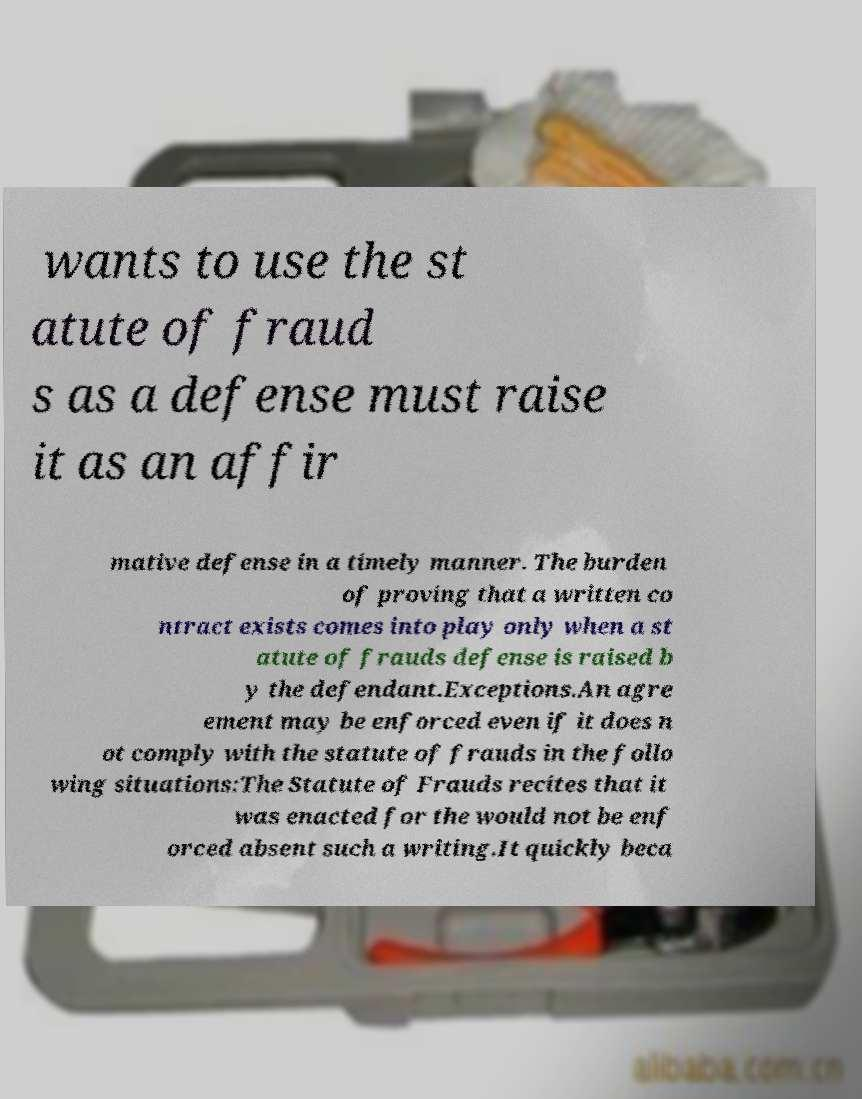What messages or text are displayed in this image? I need them in a readable, typed format. wants to use the st atute of fraud s as a defense must raise it as an affir mative defense in a timely manner. The burden of proving that a written co ntract exists comes into play only when a st atute of frauds defense is raised b y the defendant.Exceptions.An agre ement may be enforced even if it does n ot comply with the statute of frauds in the follo wing situations:The Statute of Frauds recites that it was enacted for the would not be enf orced absent such a writing.It quickly beca 